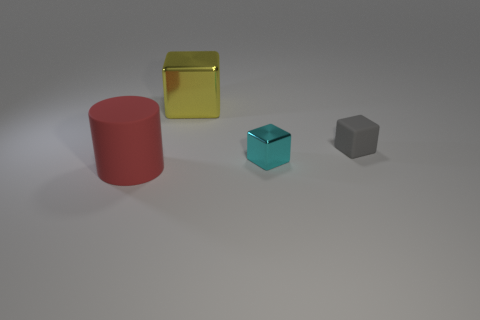What is the color of the other thing that is the same material as the tiny gray object?
Your answer should be compact. Red. What is the material of the large object that is to the right of the matte thing that is left of the large yellow metallic cube?
Your answer should be compact. Metal. How many things are large things behind the small metal thing or gray matte things on the right side of the small metal object?
Ensure brevity in your answer.  2. There is a metal object that is in front of the metallic thing to the left of the shiny thing in front of the large yellow thing; what is its size?
Keep it short and to the point. Small. Is the number of large yellow things on the left side of the tiny gray matte cube the same as the number of small yellow rubber spheres?
Your answer should be compact. No. Is there anything else that is the same shape as the red matte object?
Offer a very short reply. No. Does the gray rubber object have the same shape as the metal object that is behind the cyan metal object?
Ensure brevity in your answer.  Yes. What is the size of the yellow object that is the same shape as the gray object?
Offer a very short reply. Large. How many other things are there of the same material as the big block?
Offer a very short reply. 1. What is the gray object made of?
Your answer should be compact. Rubber. 